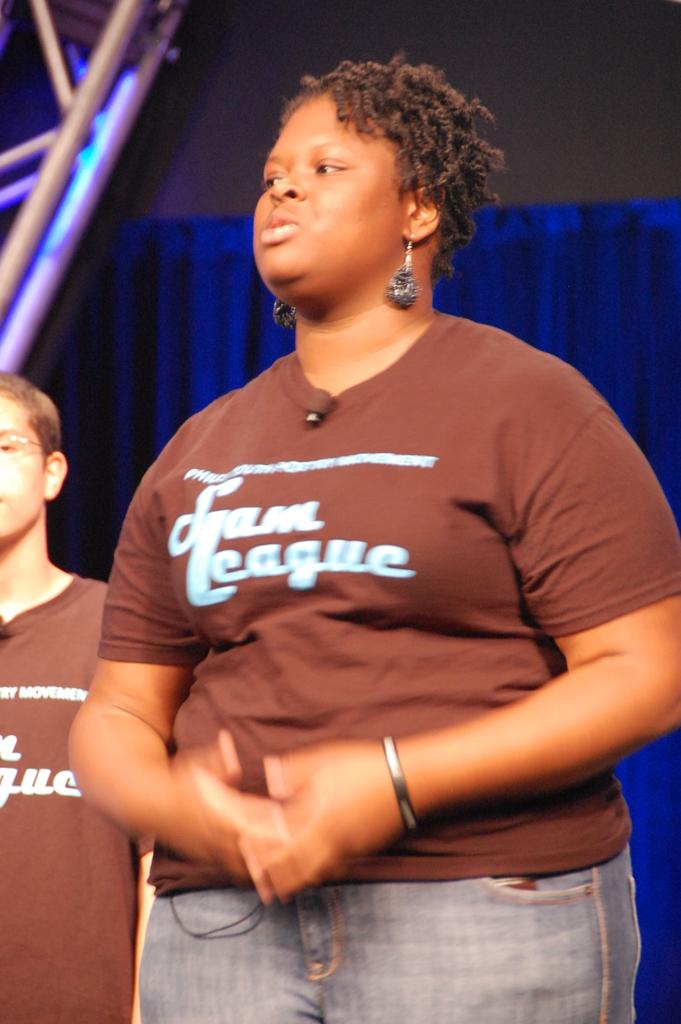<image>
Present a compact description of the photo's key features. A woman in a brown shirt that says Team League. 